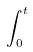<formula> <loc_0><loc_0><loc_500><loc_500>\int _ { 0 } ^ { t }</formula> 